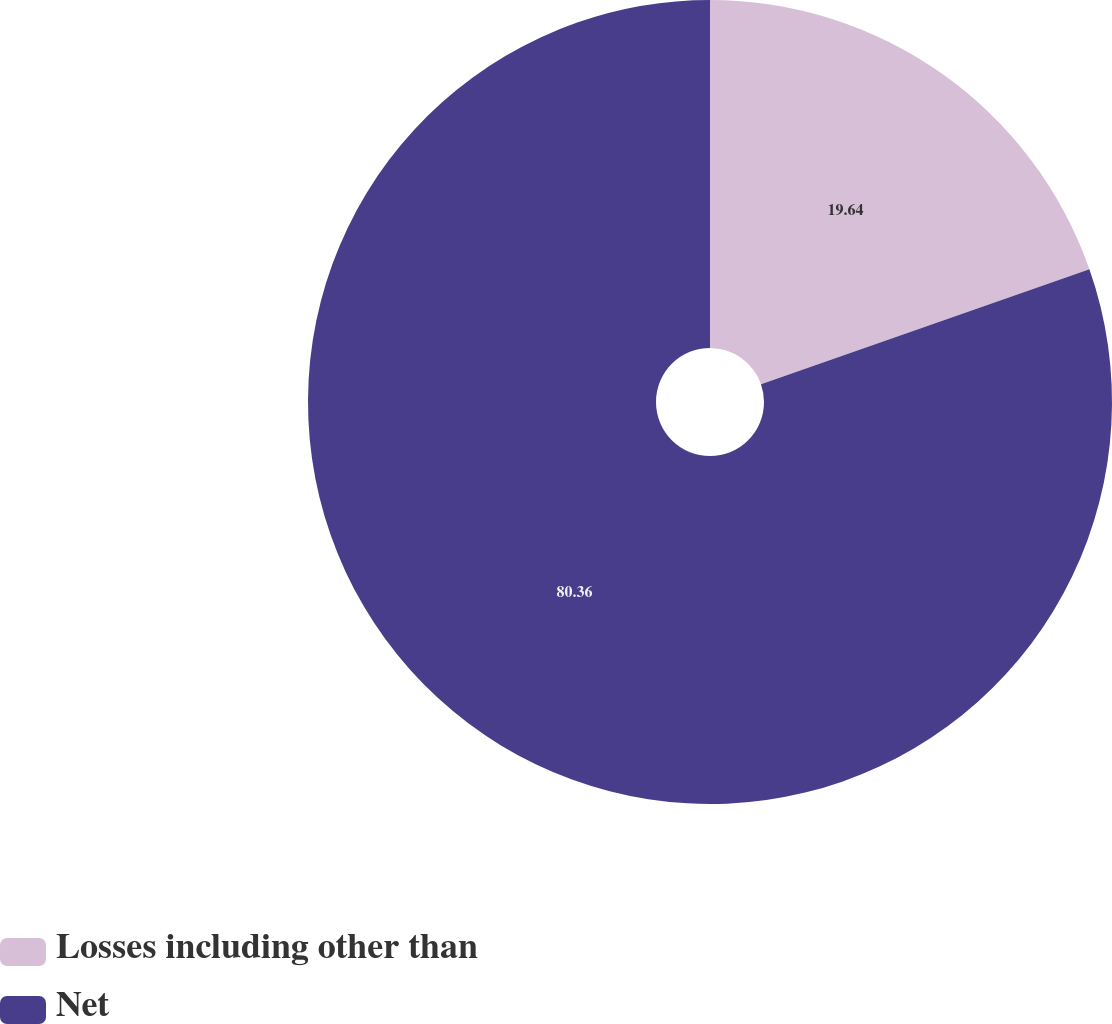Convert chart to OTSL. <chart><loc_0><loc_0><loc_500><loc_500><pie_chart><fcel>Losses including other than<fcel>Net<nl><fcel>19.64%<fcel>80.36%<nl></chart> 